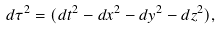Convert formula to latex. <formula><loc_0><loc_0><loc_500><loc_500>d \tau ^ { 2 } = ( d t ^ { 2 } - d x ^ { 2 } - d y ^ { 2 } - d z ^ { 2 } ) ,</formula> 